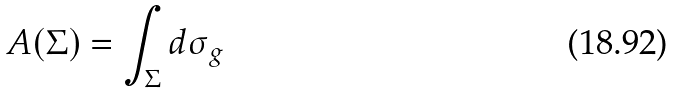<formula> <loc_0><loc_0><loc_500><loc_500>A ( \Sigma ) = \int _ { \Sigma } d { \sigma } _ { g }</formula> 